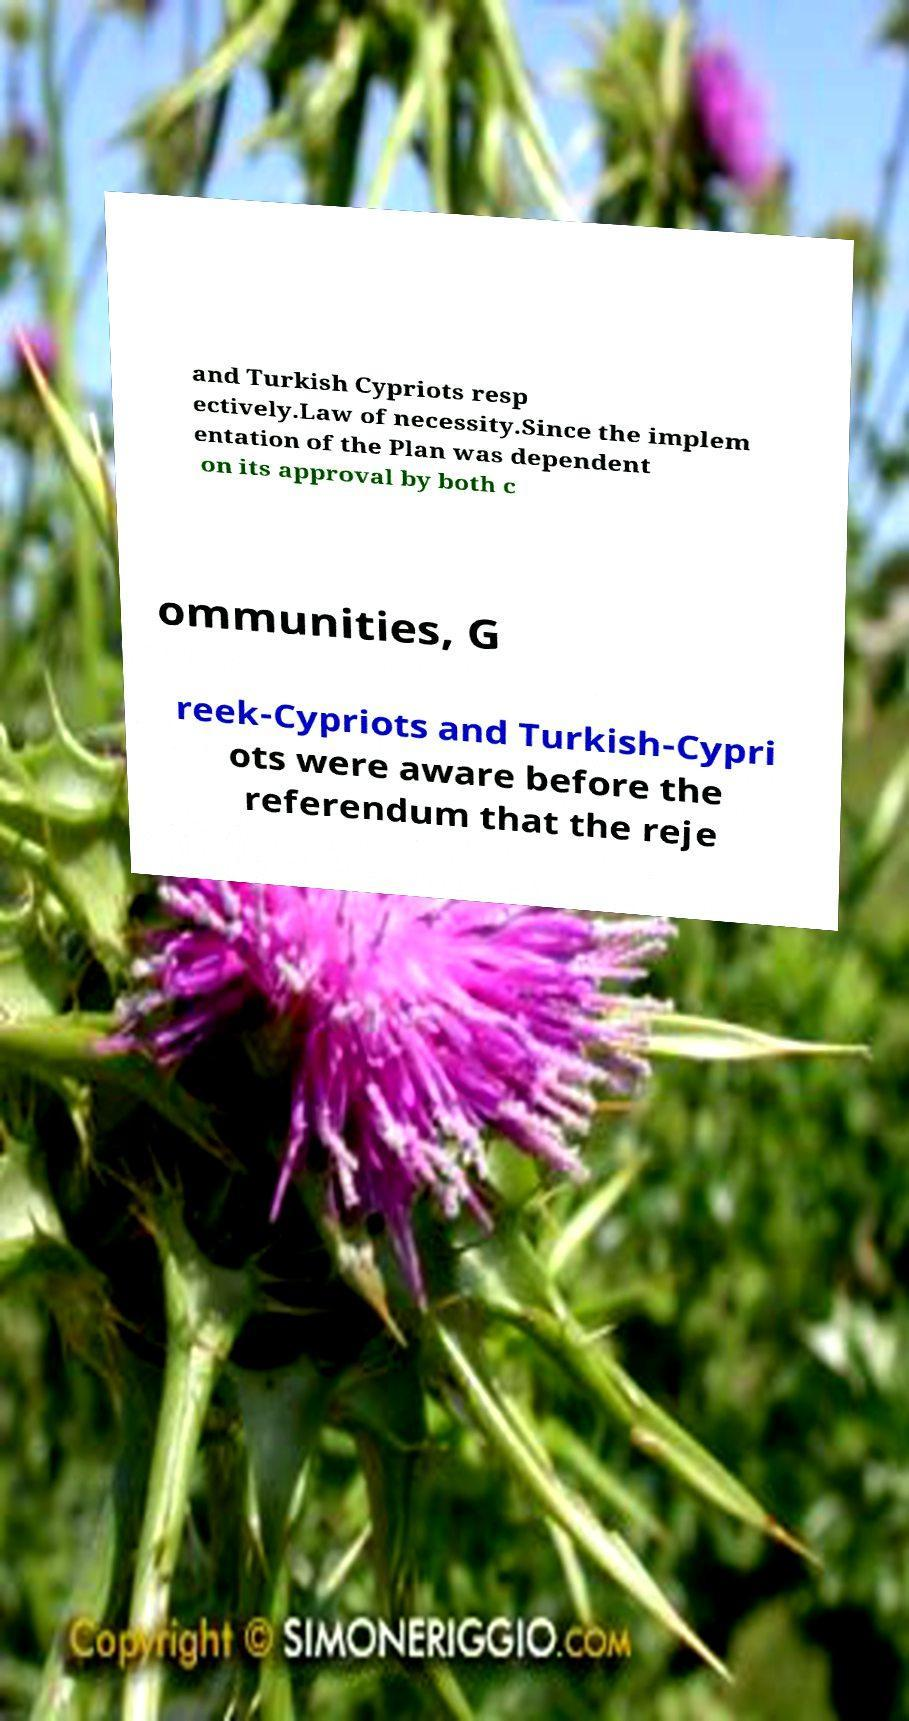I need the written content from this picture converted into text. Can you do that? and Turkish Cypriots resp ectively.Law of necessity.Since the implem entation of the Plan was dependent on its approval by both c ommunities, G reek-Cypriots and Turkish-Cypri ots were aware before the referendum that the reje 